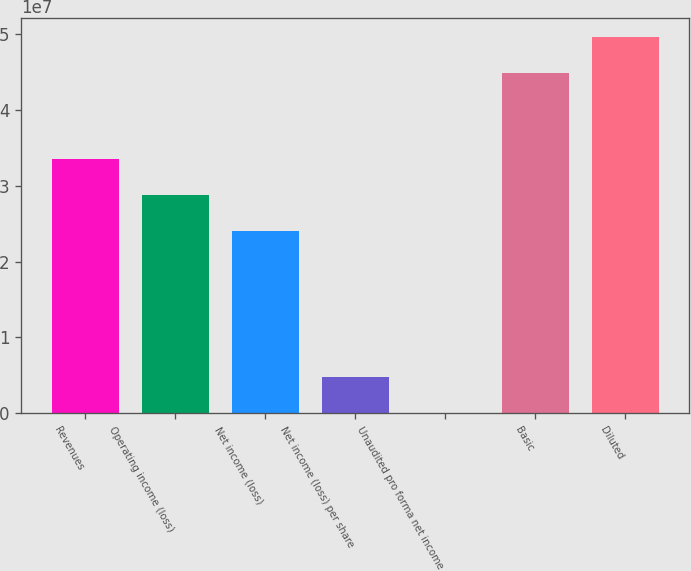Convert chart to OTSL. <chart><loc_0><loc_0><loc_500><loc_500><bar_chart><fcel>Revenues<fcel>Operating income (loss)<fcel>Net income (loss)<fcel>Net income (loss) per share<fcel>Unaudited pro forma net income<fcel>Basic<fcel>Diluted<nl><fcel>3.35426e+07<fcel>2.87508e+07<fcel>2.3959e+07<fcel>4.7918e+06<fcel>0.04<fcel>4.48578e+07<fcel>4.96496e+07<nl></chart> 